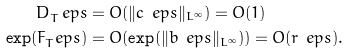Convert formula to latex. <formula><loc_0><loc_0><loc_500><loc_500>D _ { T } ^ { \ } e p s & = O ( \| c _ { \ } e p s \| _ { L ^ { \infty } } ) = O ( 1 ) \\ \exp ( F _ { T } ^ { \ } e p s ) & = O ( \exp ( \| b _ { \ } e p s \| _ { L ^ { \infty } } ) ) = O ( r _ { \ } e p s ) .</formula> 